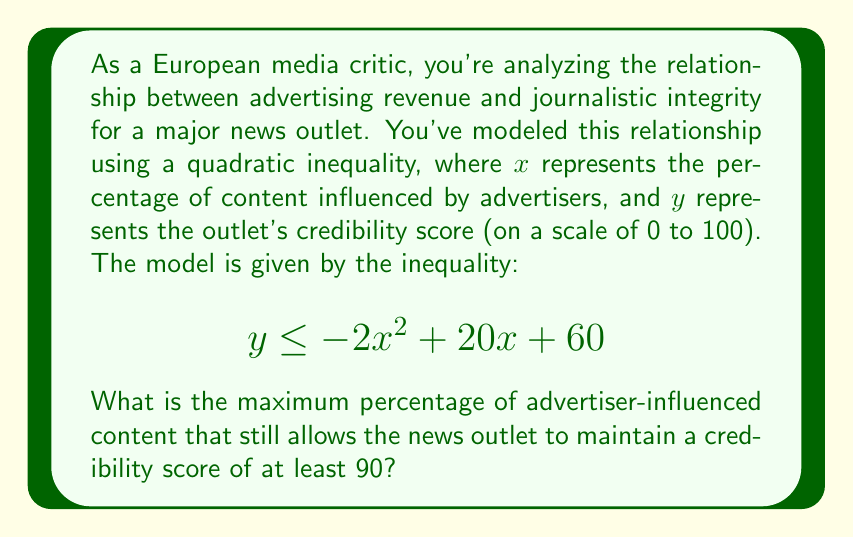Can you answer this question? To solve this problem, we need to follow these steps:

1) We're looking for the maximum value of $x$ where $y \geq 90$. This means we need to solve the inequality:

   $$90 \leq -2x^2 + 20x + 60$$

2) Rearrange the inequality:

   $$0 \leq -2x^2 + 20x - 30$$

3) This is a quadratic inequality. To solve it, we first need to find the roots of the quadratic equation:

   $$-2x^2 + 20x - 30 = 0$$

4) We can solve this using the quadratic formula: $x = \frac{-b \pm \sqrt{b^2 - 4ac}}{2a}$

   Here, $a = -2$, $b = 20$, and $c = -30$

5) Plugging into the formula:

   $$x = \frac{-20 \pm \sqrt{400 - 4(-2)(-30)}}{2(-2)}$$
   $$= \frac{-20 \pm \sqrt{400 - 240}}{-4}$$
   $$= \frac{-20 \pm \sqrt{160}}{-4}$$
   $$= \frac{-20 \pm 4\sqrt{10}}{-4}$$

6) This gives us two solutions:

   $$x_1 = \frac{-20 + 4\sqrt{10}}{-4} = 5 - \sqrt{10} \approx 1.84$$
   $$x_2 = \frac{-20 - 4\sqrt{10}}{-4} = 5 + \sqrt{10} \approx 8.16$$

7) The inequality is satisfied when $x$ is between these two values. Since we're looking for the maximum percentage, we want the larger value.

8) Converting to a percentage, we get: $8.16 \times 100\% = 81.6\%$

Therefore, the maximum percentage of advertiser-influenced content that still allows a credibility score of at least 90 is approximately 81.6%.
Answer: The maximum percentage of advertiser-influenced content is approximately 81.6%. 